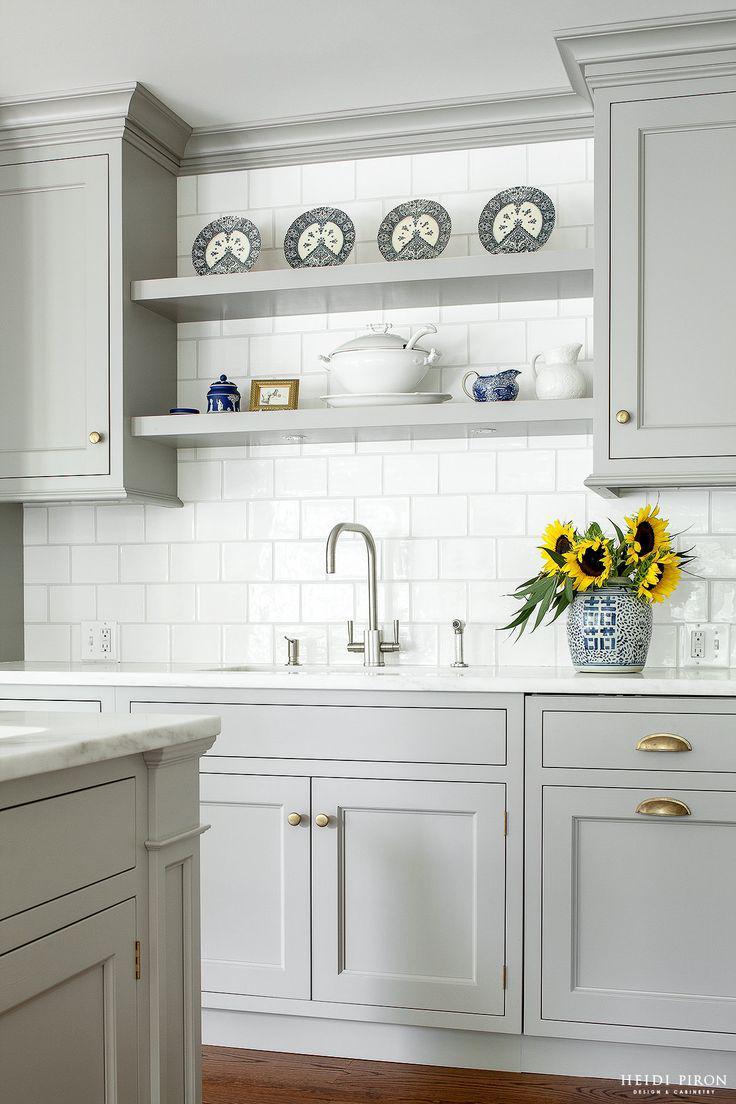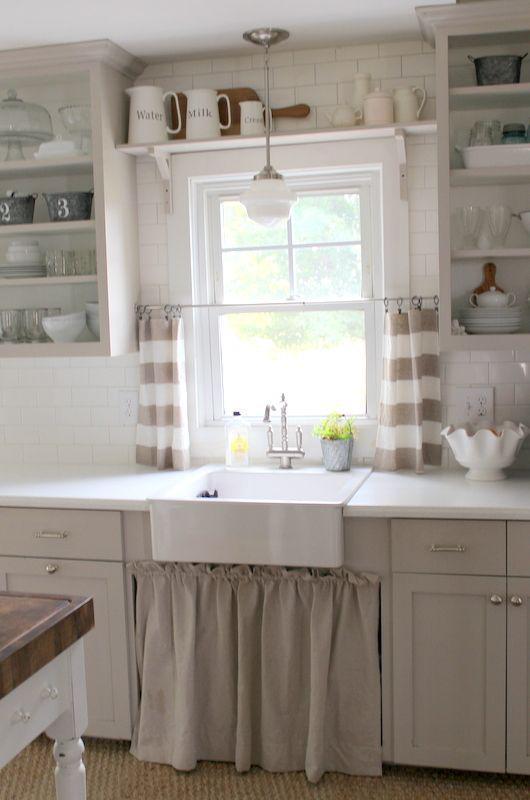The first image is the image on the left, the second image is the image on the right. Given the left and right images, does the statement "One kitchen has something decorative above and behind the sink, instead of a window to the outdoors." hold true? Answer yes or no. Yes. 